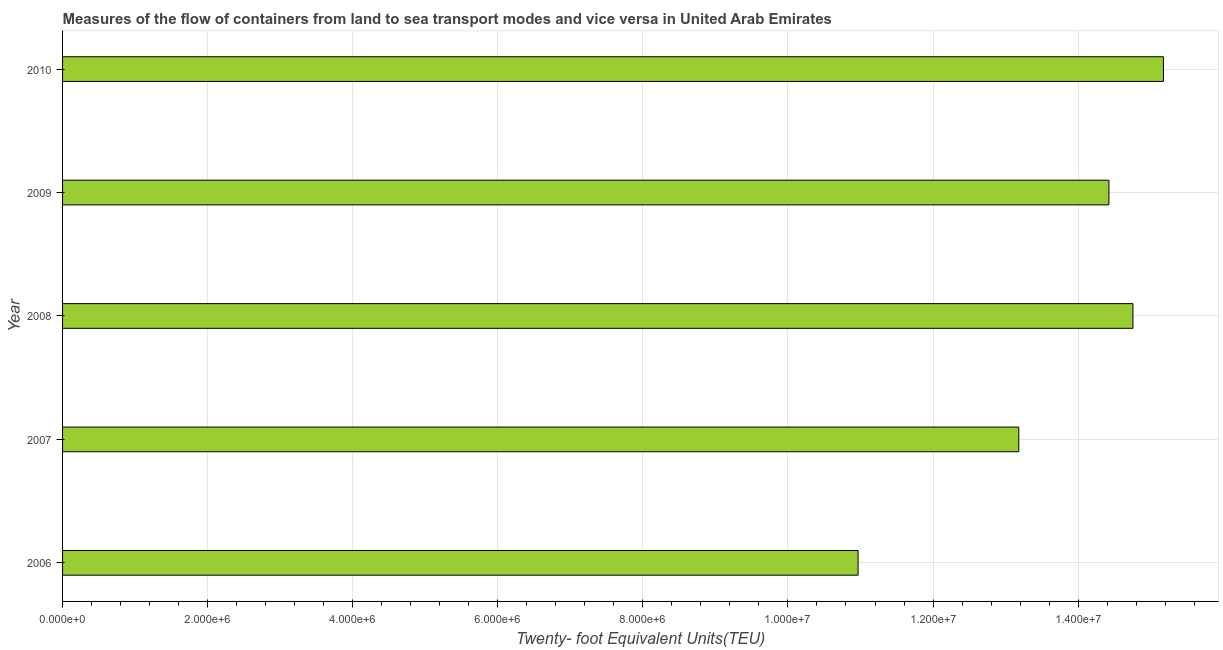Does the graph contain grids?
Ensure brevity in your answer.  Yes. What is the title of the graph?
Offer a terse response. Measures of the flow of containers from land to sea transport modes and vice versa in United Arab Emirates. What is the label or title of the X-axis?
Offer a terse response. Twenty- foot Equivalent Units(TEU). What is the container port traffic in 2007?
Keep it short and to the point. 1.32e+07. Across all years, what is the maximum container port traffic?
Your answer should be compact. 1.52e+07. Across all years, what is the minimum container port traffic?
Offer a very short reply. 1.10e+07. In which year was the container port traffic maximum?
Your response must be concise. 2010. In which year was the container port traffic minimum?
Provide a short and direct response. 2006. What is the sum of the container port traffic?
Ensure brevity in your answer.  6.85e+07. What is the difference between the container port traffic in 2006 and 2009?
Make the answer very short. -3.46e+06. What is the average container port traffic per year?
Your answer should be compact. 1.37e+07. What is the median container port traffic?
Your response must be concise. 1.44e+07. In how many years, is the container port traffic greater than 10000000 TEU?
Your answer should be very brief. 5. What is the ratio of the container port traffic in 2006 to that in 2009?
Your response must be concise. 0.76. Is the difference between the container port traffic in 2008 and 2010 greater than the difference between any two years?
Ensure brevity in your answer.  No. What is the difference between the highest and the second highest container port traffic?
Ensure brevity in your answer.  4.20e+05. What is the difference between the highest and the lowest container port traffic?
Your response must be concise. 4.21e+06. In how many years, is the container port traffic greater than the average container port traffic taken over all years?
Provide a succinct answer. 3. How many years are there in the graph?
Keep it short and to the point. 5. What is the difference between two consecutive major ticks on the X-axis?
Ensure brevity in your answer.  2.00e+06. Are the values on the major ticks of X-axis written in scientific E-notation?
Your response must be concise. Yes. What is the Twenty- foot Equivalent Units(TEU) of 2006?
Provide a succinct answer. 1.10e+07. What is the Twenty- foot Equivalent Units(TEU) of 2007?
Provide a short and direct response. 1.32e+07. What is the Twenty- foot Equivalent Units(TEU) in 2008?
Your answer should be very brief. 1.48e+07. What is the Twenty- foot Equivalent Units(TEU) of 2009?
Keep it short and to the point. 1.44e+07. What is the Twenty- foot Equivalent Units(TEU) of 2010?
Your answer should be very brief. 1.52e+07. What is the difference between the Twenty- foot Equivalent Units(TEU) in 2006 and 2007?
Offer a terse response. -2.22e+06. What is the difference between the Twenty- foot Equivalent Units(TEU) in 2006 and 2008?
Make the answer very short. -3.79e+06. What is the difference between the Twenty- foot Equivalent Units(TEU) in 2006 and 2009?
Provide a succinct answer. -3.46e+06. What is the difference between the Twenty- foot Equivalent Units(TEU) in 2006 and 2010?
Provide a short and direct response. -4.21e+06. What is the difference between the Twenty- foot Equivalent Units(TEU) in 2007 and 2008?
Give a very brief answer. -1.57e+06. What is the difference between the Twenty- foot Equivalent Units(TEU) in 2007 and 2009?
Your response must be concise. -1.24e+06. What is the difference between the Twenty- foot Equivalent Units(TEU) in 2007 and 2010?
Provide a succinct answer. -1.99e+06. What is the difference between the Twenty- foot Equivalent Units(TEU) in 2008 and 2009?
Provide a succinct answer. 3.31e+05. What is the difference between the Twenty- foot Equivalent Units(TEU) in 2008 and 2010?
Your answer should be compact. -4.20e+05. What is the difference between the Twenty- foot Equivalent Units(TEU) in 2009 and 2010?
Ensure brevity in your answer.  -7.51e+05. What is the ratio of the Twenty- foot Equivalent Units(TEU) in 2006 to that in 2007?
Your answer should be compact. 0.83. What is the ratio of the Twenty- foot Equivalent Units(TEU) in 2006 to that in 2008?
Provide a succinct answer. 0.74. What is the ratio of the Twenty- foot Equivalent Units(TEU) in 2006 to that in 2009?
Your answer should be compact. 0.76. What is the ratio of the Twenty- foot Equivalent Units(TEU) in 2006 to that in 2010?
Provide a short and direct response. 0.72. What is the ratio of the Twenty- foot Equivalent Units(TEU) in 2007 to that in 2008?
Offer a terse response. 0.89. What is the ratio of the Twenty- foot Equivalent Units(TEU) in 2007 to that in 2009?
Provide a short and direct response. 0.91. What is the ratio of the Twenty- foot Equivalent Units(TEU) in 2007 to that in 2010?
Your answer should be compact. 0.87. What is the ratio of the Twenty- foot Equivalent Units(TEU) in 2008 to that in 2010?
Offer a very short reply. 0.97. What is the ratio of the Twenty- foot Equivalent Units(TEU) in 2009 to that in 2010?
Offer a very short reply. 0.95. 